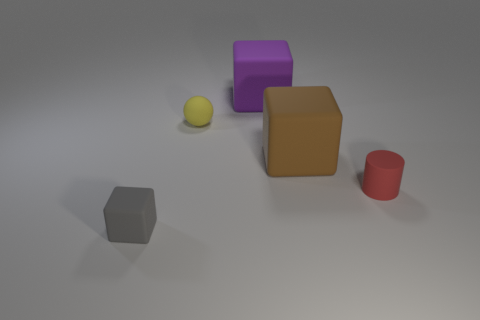Add 1 small cyan metallic cylinders. How many objects exist? 6 Subtract all spheres. How many objects are left? 4 Subtract all large rubber things. Subtract all small rubber cylinders. How many objects are left? 2 Add 2 purple matte blocks. How many purple matte blocks are left? 3 Add 4 purple objects. How many purple objects exist? 5 Subtract 1 gray cubes. How many objects are left? 4 